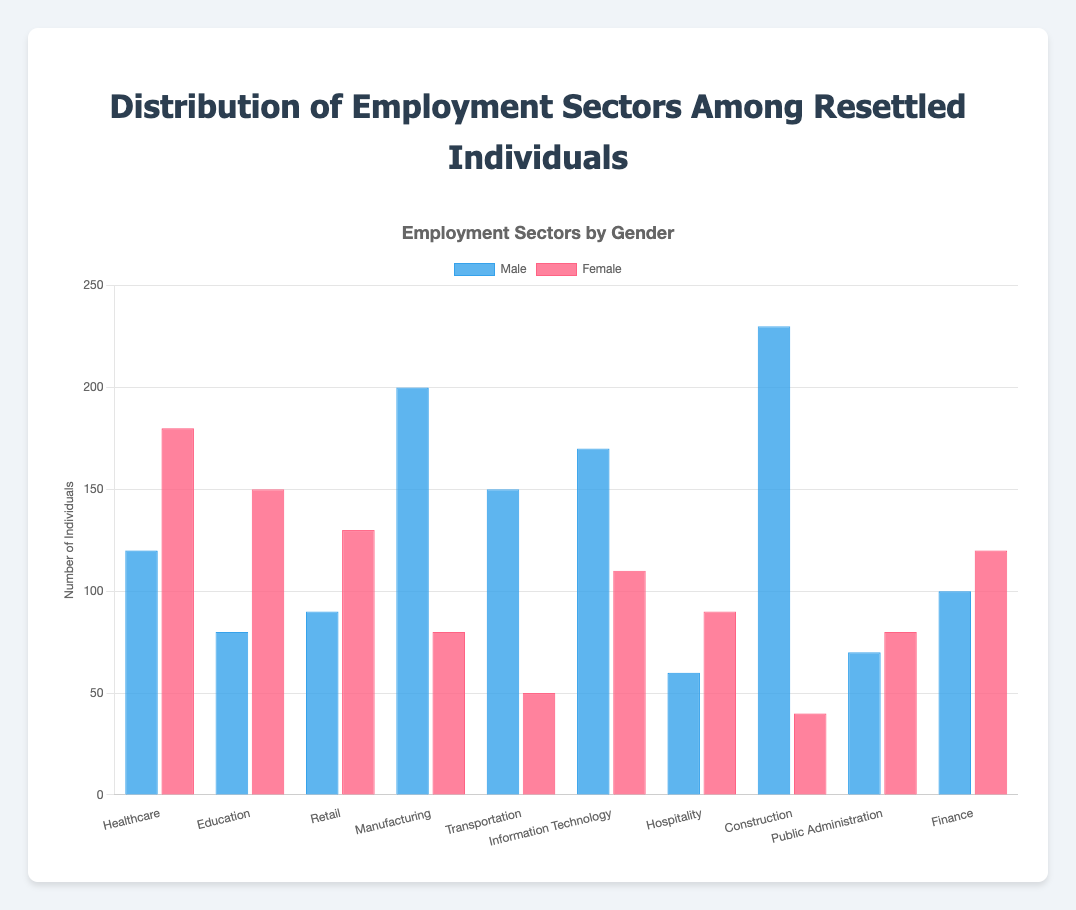Which employment sector has the highest number of males? By observing the height of the blue bars (representing males) in each sector, identify the tallest bar. The tallest bar is in the Construction sector.
Answer: Construction What is the total number of females in the Healthcare and Education sectors? Add the values for females in the Healthcare (180) and Education (150) sectors: 180 + 150 = 330.
Answer: 330 Which sector shows the greatest difference between male and female employees? For each sector, calculate the absolute value of the difference between males and females, then identify the sector with the largest value. The differences are: Healthcare (60), Education (70), Retail (40), Manufacturing (120), Transportation (100), Information Technology (60), Hospitality (30), Construction (190), Public Administration (10), Finance (20). The greatest difference is in Construction.
Answer: Construction How many sectors employ more females than males? Compare the values of males and females for each sector: Healthcare (more females), Education (more females), Retail (more females), Manufacturing (more males), Transportation (more males), Information Technology (more males), Hospitality (more females), Construction (more males), Public Administration (more females), Finance (more females). There are 5 sectors with more females.
Answer: 5 Which sector has the least number of males, and what is that number? Identify the shortest blue bar in the chart, which represents males in the Hospitality sector, and note the value (60).
Answer: Hospitality, 60 